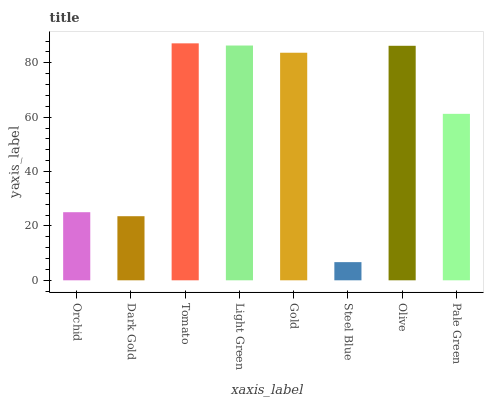Is Steel Blue the minimum?
Answer yes or no. Yes. Is Tomato the maximum?
Answer yes or no. Yes. Is Dark Gold the minimum?
Answer yes or no. No. Is Dark Gold the maximum?
Answer yes or no. No. Is Orchid greater than Dark Gold?
Answer yes or no. Yes. Is Dark Gold less than Orchid?
Answer yes or no. Yes. Is Dark Gold greater than Orchid?
Answer yes or no. No. Is Orchid less than Dark Gold?
Answer yes or no. No. Is Gold the high median?
Answer yes or no. Yes. Is Pale Green the low median?
Answer yes or no. Yes. Is Steel Blue the high median?
Answer yes or no. No. Is Steel Blue the low median?
Answer yes or no. No. 